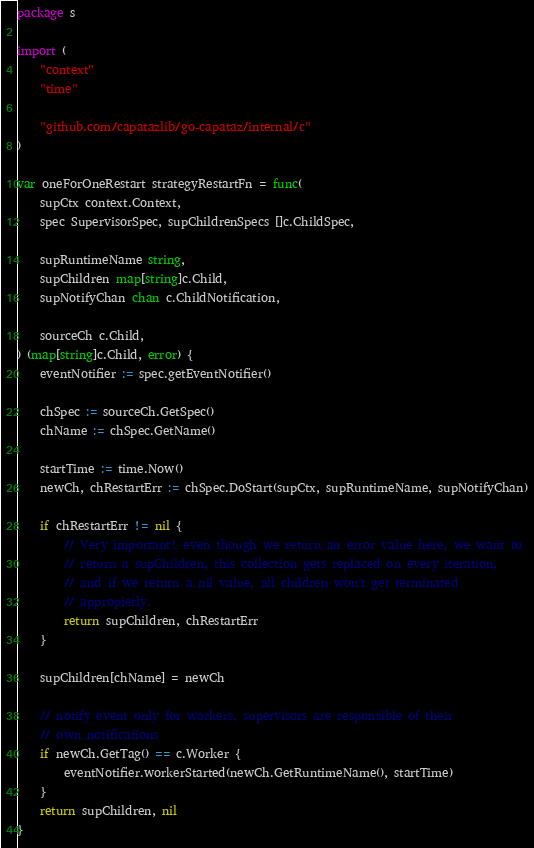<code> <loc_0><loc_0><loc_500><loc_500><_Go_>package s

import (
	"context"
	"time"

	"github.com/capatazlib/go-capataz/internal/c"
)

var oneForOneRestart strategyRestartFn = func(
	supCtx context.Context,
	spec SupervisorSpec, supChildrenSpecs []c.ChildSpec,

	supRuntimeName string,
	supChildren map[string]c.Child,
	supNotifyChan chan c.ChildNotification,

	sourceCh c.Child,
) (map[string]c.Child, error) {
	eventNotifier := spec.getEventNotifier()

	chSpec := sourceCh.GetSpec()
	chName := chSpec.GetName()

	startTime := time.Now()
	newCh, chRestartErr := chSpec.DoStart(supCtx, supRuntimeName, supNotifyChan)

	if chRestartErr != nil {
		// Very important! even though we return an error value here, we want to
		// return a supChildren, this collection gets replaced on every iteration,
		// and if we return a nil value, all children won't get terminated
		// appropietly.
		return supChildren, chRestartErr
	}

	supChildren[chName] = newCh

	// notify event only for workers, supervisors are responsible of their
	// own notifications
	if newCh.GetTag() == c.Worker {
		eventNotifier.workerStarted(newCh.GetRuntimeName(), startTime)
	}
	return supChildren, nil
}
</code> 